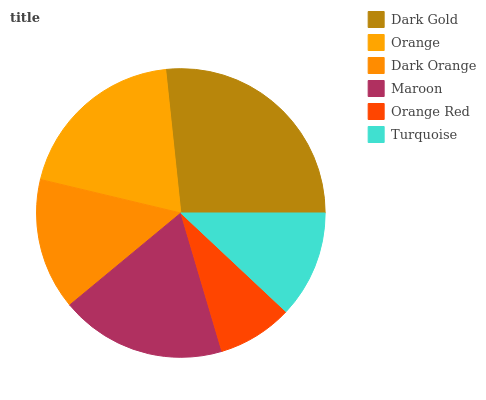Is Orange Red the minimum?
Answer yes or no. Yes. Is Dark Gold the maximum?
Answer yes or no. Yes. Is Orange the minimum?
Answer yes or no. No. Is Orange the maximum?
Answer yes or no. No. Is Dark Gold greater than Orange?
Answer yes or no. Yes. Is Orange less than Dark Gold?
Answer yes or no. Yes. Is Orange greater than Dark Gold?
Answer yes or no. No. Is Dark Gold less than Orange?
Answer yes or no. No. Is Maroon the high median?
Answer yes or no. Yes. Is Dark Orange the low median?
Answer yes or no. Yes. Is Turquoise the high median?
Answer yes or no. No. Is Orange Red the low median?
Answer yes or no. No. 